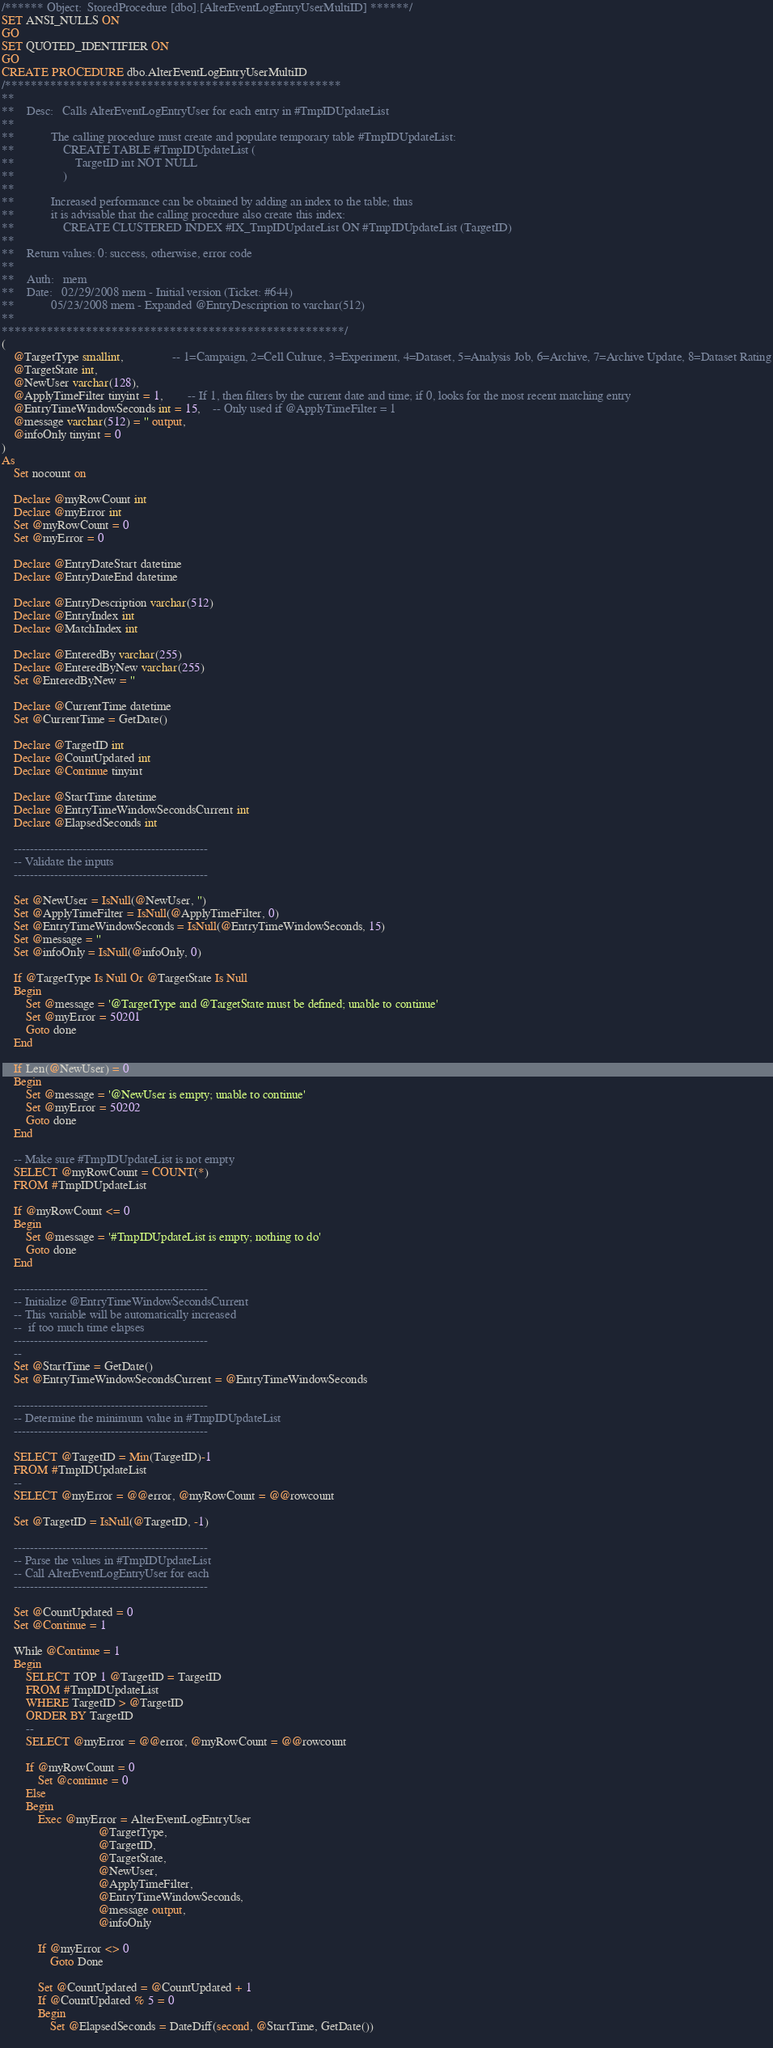Convert code to text. <code><loc_0><loc_0><loc_500><loc_500><_SQL_>/****** Object:  StoredProcedure [dbo].[AlterEventLogEntryUserMultiID] ******/
SET ANSI_NULLS ON
GO
SET QUOTED_IDENTIFIER ON
GO
CREATE PROCEDURE dbo.AlterEventLogEntryUserMultiID
/****************************************************
**
**	Desc:	Calls AlterEventLogEntryUser for each entry in #TmpIDUpdateList
**
**			The calling procedure must create and populate temporary table #TmpIDUpdateList:
**				CREATE TABLE #TmpIDUpdateList (
**					TargetID int NOT NULL
**				)
**
**			Increased performance can be obtained by adding an index to the table; thus
**			it is advisable that the calling procedure also create this index:		
**				CREATE CLUSTERED INDEX #IX_TmpIDUpdateList ON #TmpIDUpdateList (TargetID)
**
**	Return values: 0: success, otherwise, error code
**
**	Auth:	mem
**	Date:	02/29/2008 mem - Initial version (Ticket: #644)
**			05/23/2008 mem - Expanded @EntryDescription to varchar(512)
**    
*****************************************************/
(
	@TargetType smallint,				-- 1=Campaign, 2=Cell Culture, 3=Experiment, 4=Dataset, 5=Analysis Job, 6=Archive, 7=Archive Update, 8=Dataset Rating
	@TargetState int,
	@NewUser varchar(128),
	@ApplyTimeFilter tinyint = 1,		-- If 1, then filters by the current date and time; if 0, looks for the most recent matching entry
	@EntryTimeWindowSeconds int = 15,	-- Only used if @ApplyTimeFilter = 1
	@message varchar(512) = '' output,
	@infoOnly tinyint = 0
)
As
	Set nocount on
	
	Declare @myRowCount int
	Declare @myError int
	Set @myRowCount = 0
	Set @myError = 0

	Declare @EntryDateStart datetime
	Declare @EntryDateEnd datetime

	Declare @EntryDescription varchar(512)
	Declare @EntryIndex int
	Declare @MatchIndex int
	
	Declare @EnteredBy varchar(255)
	Declare @EnteredByNew varchar(255)
	Set @EnteredByNew = ''
	
	Declare @CurrentTime datetime
	Set @CurrentTime = GetDate()

	Declare @TargetID int
	Declare @CountUpdated int
	Declare @Continue tinyint

	Declare @StartTime datetime
	Declare @EntryTimeWindowSecondsCurrent int
	Declare @ElapsedSeconds int
	
	------------------------------------------------
	-- Validate the inputs
	------------------------------------------------
	
	Set @NewUser = IsNull(@NewUser, '')
	Set @ApplyTimeFilter = IsNull(@ApplyTimeFilter, 0)
	Set @EntryTimeWindowSeconds = IsNull(@EntryTimeWindowSeconds, 15)
	Set @message = ''
	Set @infoOnly = IsNull(@infoOnly, 0)

	If @TargetType Is Null Or @TargetState Is Null
	Begin
		Set @message = '@TargetType and @TargetState must be defined; unable to continue'
		Set @myError = 50201
		Goto done
	End
	
	If Len(@NewUser) = 0
	Begin
		Set @message = '@NewUser is empty; unable to continue'
		Set @myError = 50202
		Goto done
	End

	-- Make sure #TmpIDUpdateList is not empty
	SELECT @myRowCount = COUNT(*)
	FROM #TmpIDUpdateList
	
	If @myRowCount <= 0
	Begin
		Set @message = '#TmpIDUpdateList is empty; nothing to do'
		Goto done
	End

	------------------------------------------------
	-- Initialize @EntryTimeWindowSecondsCurrent
	-- This variable will be automatically increased 
	--  if too much time elapses
	------------------------------------------------
	--
	Set @StartTime = GetDate()
	Set @EntryTimeWindowSecondsCurrent = @EntryTimeWindowSeconds
	
	------------------------------------------------
	-- Determine the minimum value in #TmpIDUpdateList
	------------------------------------------------

	SELECT @TargetID = Min(TargetID)-1
	FROM #TmpIDUpdateList
	--
	SELECT @myError = @@error, @myRowCount = @@rowcount
	
	Set @TargetID = IsNull(@TargetID, -1)
	
	------------------------------------------------
	-- Parse the values in #TmpIDUpdateList
	-- Call AlterEventLogEntryUser for each
	------------------------------------------------
	
	Set @CountUpdated = 0
	Set @Continue = 1
	
	While @Continue = 1
	Begin
		SELECT TOP 1 @TargetID = TargetID
		FROM #TmpIDUpdateList
		WHERE TargetID > @TargetID
		ORDER BY TargetID
		--
		SELECT @myError = @@error, @myRowCount = @@rowcount
	
		If @myRowCount = 0
			Set @continue = 0
		Else
		Begin
			Exec @myError = AlterEventLogEntryUser
								@TargetType,
								@TargetID,
								@TargetState,
								@NewUser,
								@ApplyTimeFilter,
								@EntryTimeWindowSeconds,
								@message output,
								@infoOnly

			If @myError <> 0
				Goto Done
			
			Set @CountUpdated = @CountUpdated + 1
			If @CountUpdated % 5 = 0
			Begin
				Set @ElapsedSeconds = DateDiff(second, @StartTime, GetDate())
				</code> 